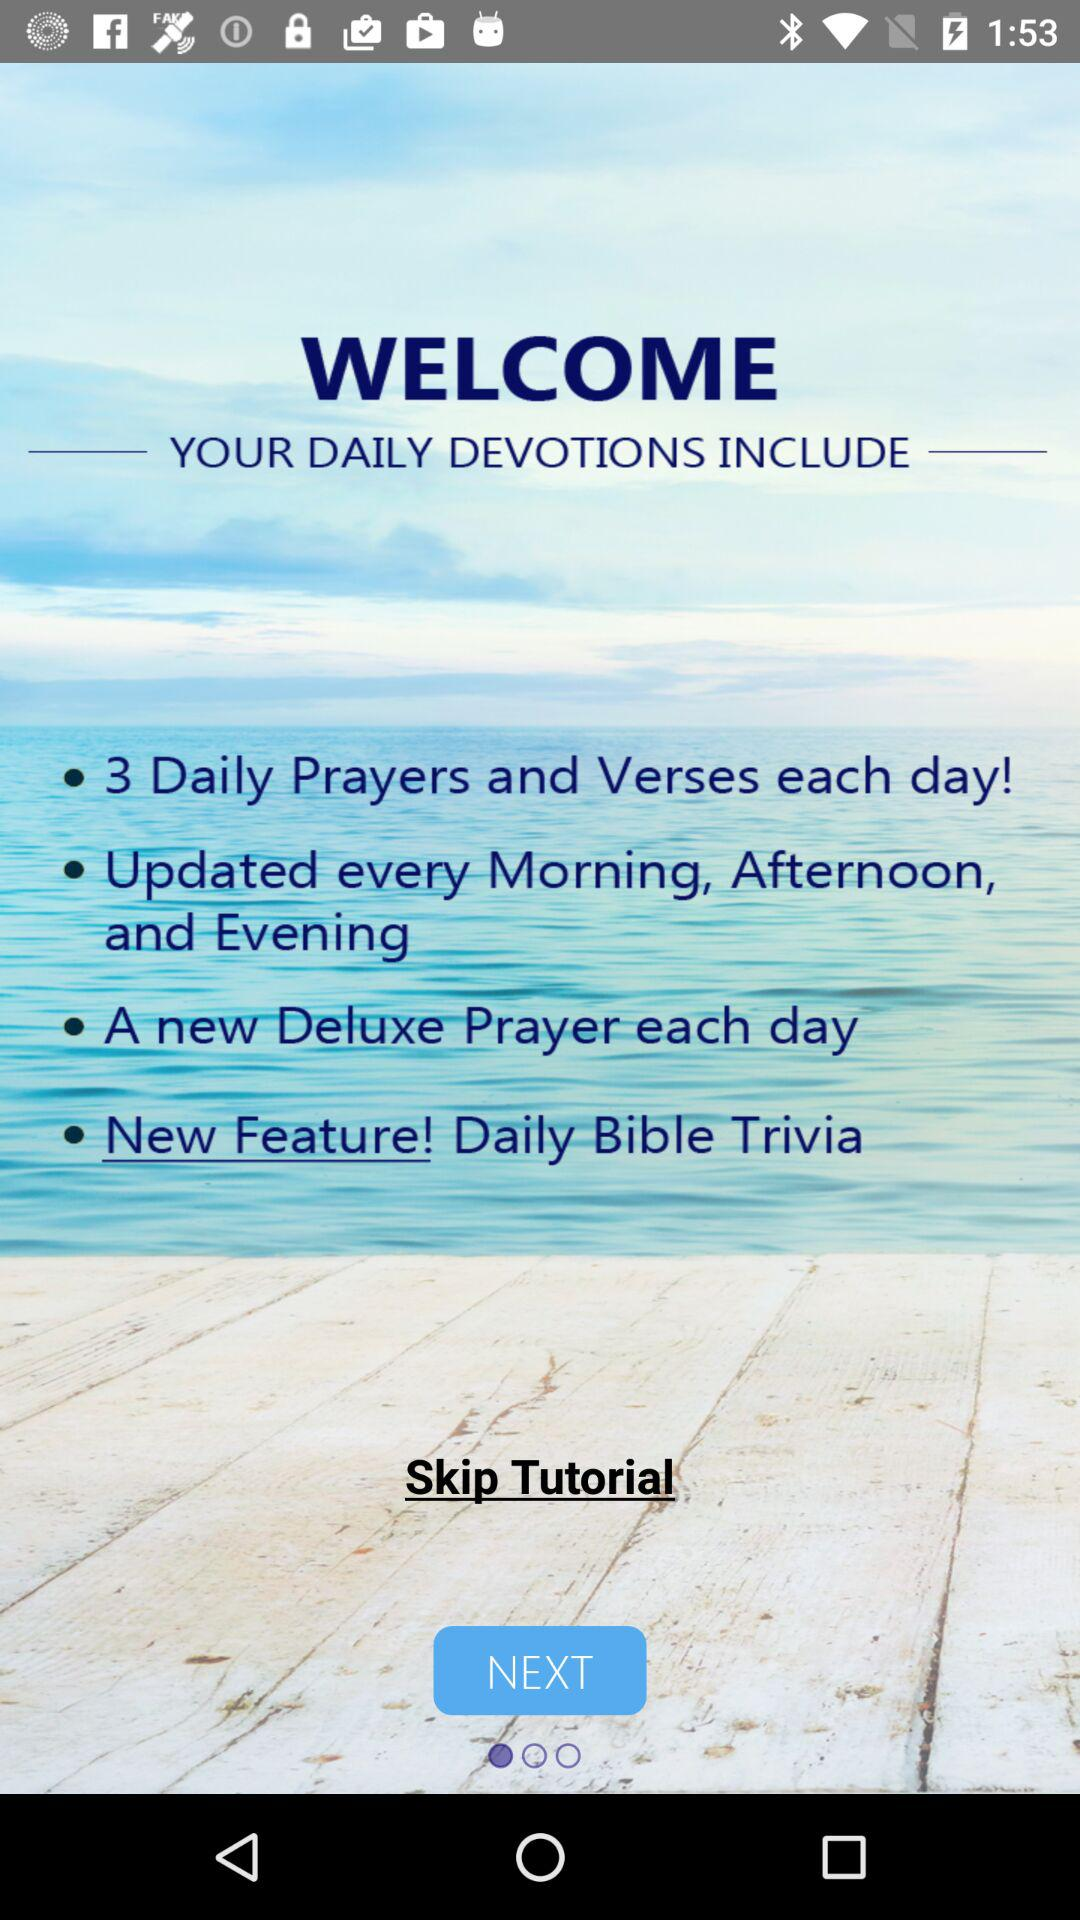How long is the tutorial?
When the provided information is insufficient, respond with <no answer>. <no answer> 